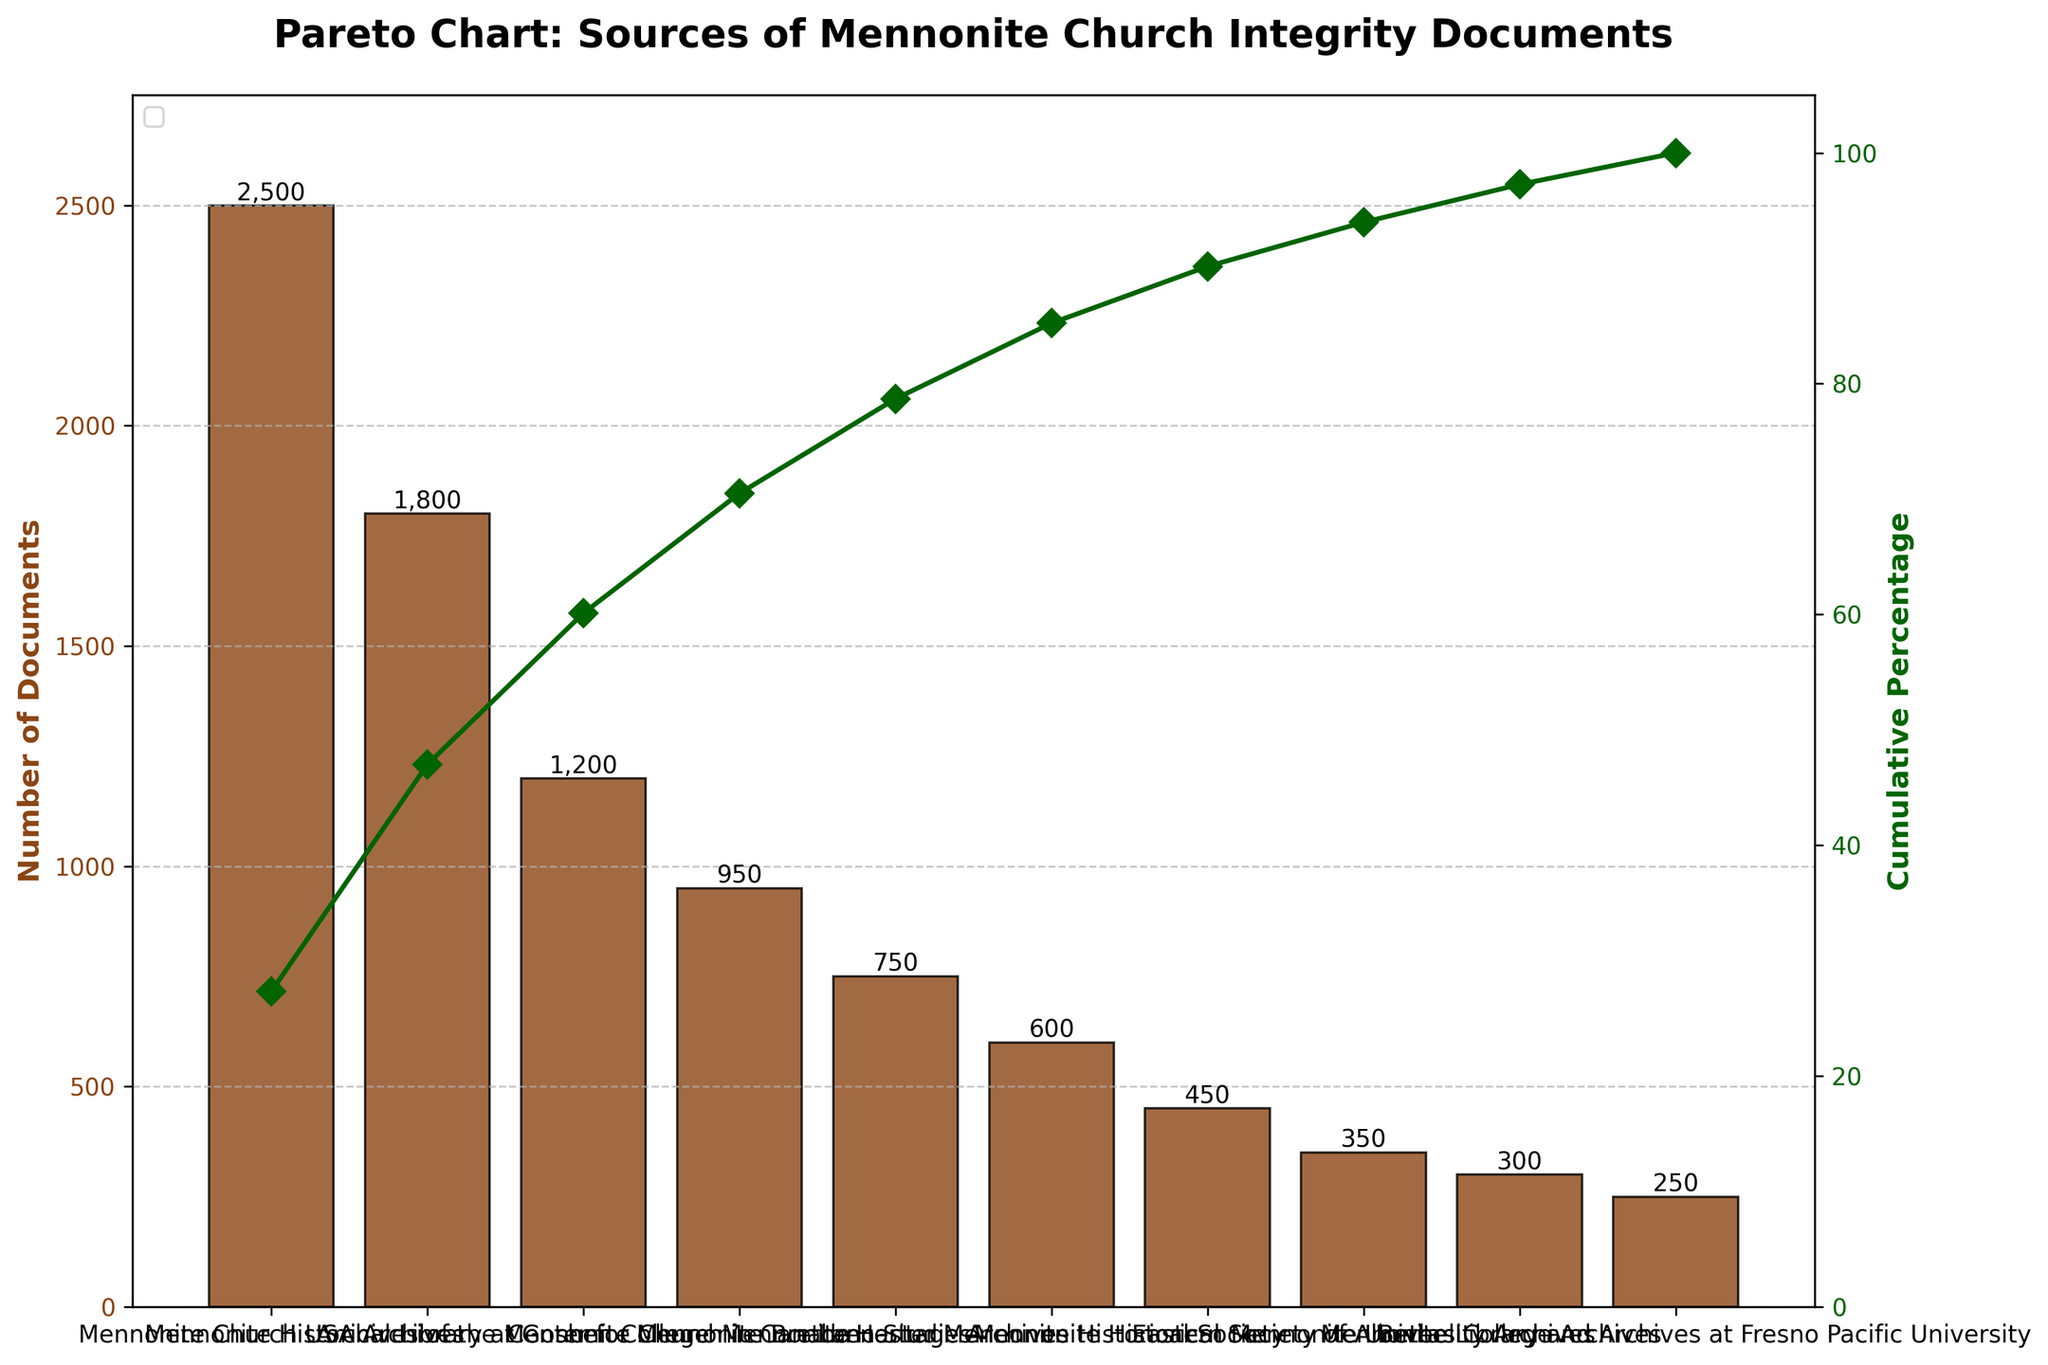What is the title of the chart? The title of the Pareto chart is displayed at the top of the figure, in bold. It reads "Pareto Chart: Sources of Mennonite Church Integrity Documents."
Answer: Pareto Chart: Sources of Mennonite Church Integrity Documents Which source has the highest number of documents? The highest bar on the chart represents the source with the most documents. The bar labeled "Mennonite Church USA Archives" is the tallest.
Answer: Mennonite Church USA Archives What is the cumulative percentage for the 'Mennonite Heritage Archives'? The cumulative percentage is shown by the line graph. By locating 'Mennonite Heritage Archives' on the x-axis and following it to the line, the point intersects at approximately 79%.
Answer: 79% How many documents are there from the Lancaster Mennonite Historical Society? The bar corresponding to the "Lancaster Mennonite Historical Society" has a label on top that shows the number of documents. The label reads "600."
Answer: 600 Which source has fewer documents: 'Bethel College Archives' or 'Eastern Mennonite University Archives'? Compare the heights of the bars for "Bethel College Archives" and "Eastern Mennonite University Archives." "Bethel College Archives" has 300 documents, which is fewer than 350 from "Eastern Mennonite University Archives."
Answer: Bethel College Archives What is the total number of documents from the top three sources? To find the total, sum the number of documents from the top three sources: Mennonite Church USA Archives (2500), Mennonite Historical Library at Goshen College (1800), and Archives of the Mennonite Church in Canada (1200). The total is 2500 + 1800 + 1200 = 5500.
Answer: 5500 How does the number of documents from the Mennonite Historical Society of Alberta compare to those from the Mennonite Heritage Archives? Compare the heights of the two bars. "Mennonite Heritage Archives" has 750 documents, whereas "Mennonite Historical Society of Alberta" has fewer, with 450 documents.
Answer: Fewer documents What is the cumulative percentage contribution of the top five sources? Sum the cumulative percentage contributions of the top five sources by locating their percentages from the line graph: Mennonite Church USA Archives (2500, ~37%), Mennonite Historical Library at Goshen College (1800, ~63%), Archives of the Mennonite Church in Canada (1200, ~78%), Center for Mennonite Brethren Studies (950, ~89%), and Mennonite Heritage Archives (750, ~95.5%). The cumulative percentage for the top five sources is approximately 95.5%.
Answer: 95.5% What percent of documents does the 'Mennonite Church USA Archives' contribute relative to the total number of documents? The chart shows 'Mennonite Church USA Archives' has 2500 documents. The total number of documents summed from the chart is 9200. So, (2500/9200) * 100 = ~27.17%.
Answer: 27.17% Which sources together contribute to at least 80% of the documents? Trace the cumulative percentage curve to identify where it reaches around 80%. The sources up to and including 'Mennonite Heritage Archives' contribute to ~79%, and adding 'Lancaster Mennonite Historical Society' brings it to ~82%. Together, these sources contribute to at least 80%: Mennonite Church USA Archives, Mennonite Historical Library at Goshen College, Archives of the Mennonite Church in Canada, Center for Mennonite Brethren Studies, Mennonite Heritage Archives, and Lancaster Mennonite Historical Society.
Answer: Mennonite Church USA Archives, Mennonite Historical Library at Goshen College, Archives of the Mennonite Church in Canada, Center for Mennonite Brethren Studies, Mennonite Heritage Archives, Lancaster Mennonite Historical Society 